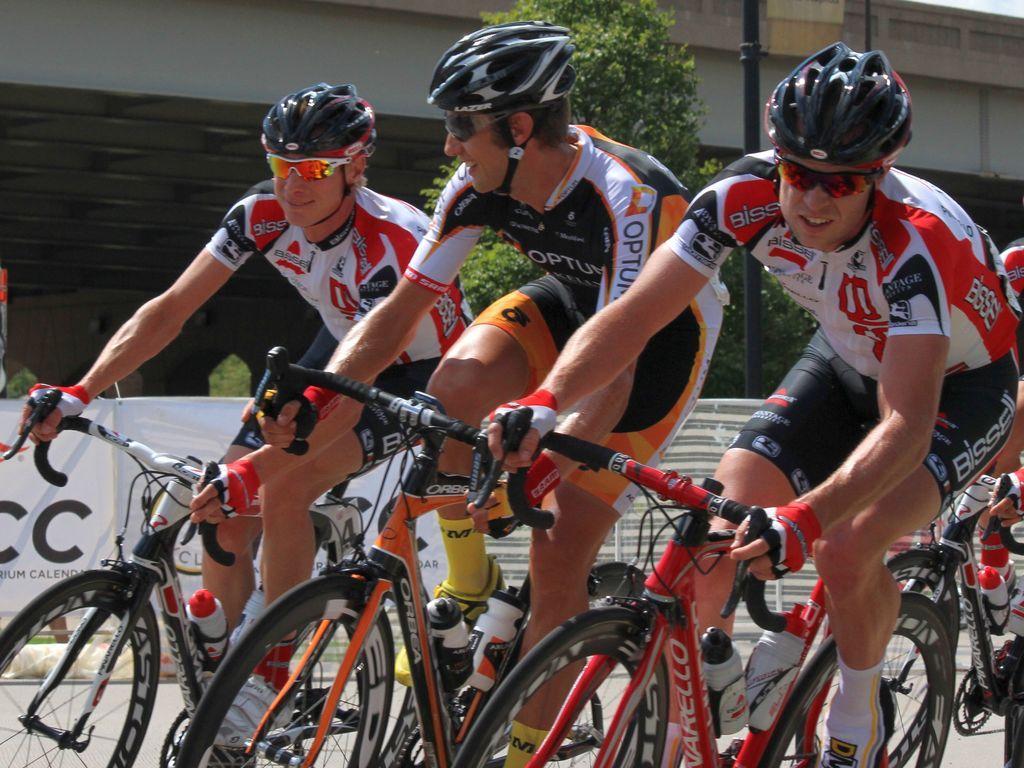Please provide a concise description of this image. In this image, we can see there are four persons in different color dresses, cycling on the road. In the background, there are banners, a tree, a pole and a building. 